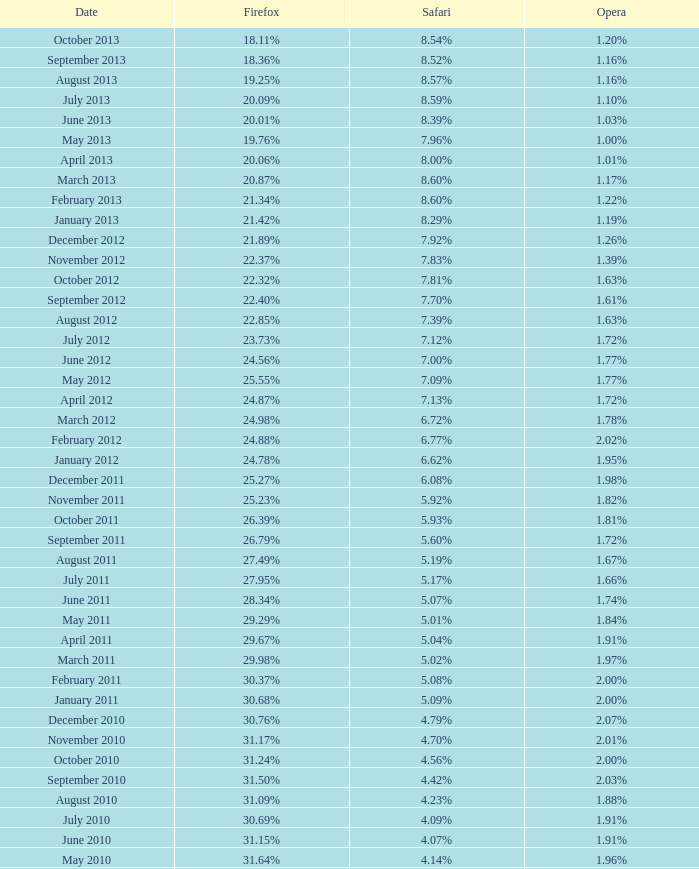What was the internet explorer usage percentage when firefox accounted for 27.85% of browser usage? 64.43%. 